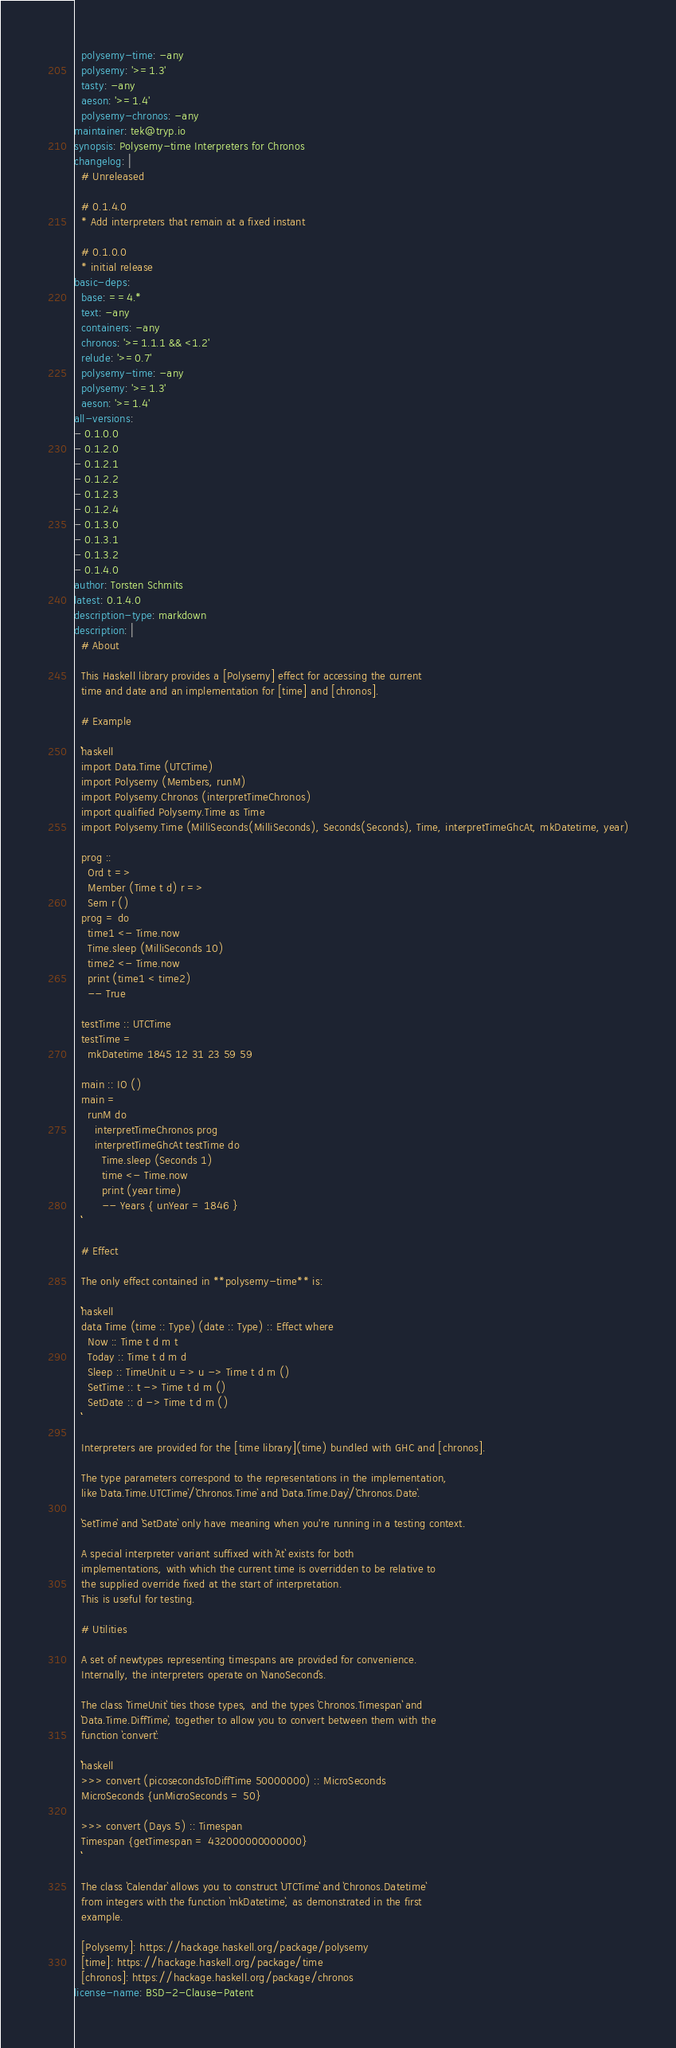Convert code to text. <code><loc_0><loc_0><loc_500><loc_500><_YAML_>  polysemy-time: -any
  polysemy: '>=1.3'
  tasty: -any
  aeson: '>=1.4'
  polysemy-chronos: -any
maintainer: tek@tryp.io
synopsis: Polysemy-time Interpreters for Chronos
changelog: |
  # Unreleased

  # 0.1.4.0
  * Add interpreters that remain at a fixed instant

  # 0.1.0.0
  * initial release
basic-deps:
  base: ==4.*
  text: -any
  containers: -any
  chronos: '>=1.1.1 && <1.2'
  relude: '>=0.7'
  polysemy-time: -any
  polysemy: '>=1.3'
  aeson: '>=1.4'
all-versions:
- 0.1.0.0
- 0.1.2.0
- 0.1.2.1
- 0.1.2.2
- 0.1.2.3
- 0.1.2.4
- 0.1.3.0
- 0.1.3.1
- 0.1.3.2
- 0.1.4.0
author: Torsten Schmits
latest: 0.1.4.0
description-type: markdown
description: |
  # About

  This Haskell library provides a [Polysemy] effect for accessing the current
  time and date and an implementation for [time] and [chronos].

  # Example

  ```haskell
  import Data.Time (UTCTime)
  import Polysemy (Members, runM)
  import Polysemy.Chronos (interpretTimeChronos)
  import qualified Polysemy.Time as Time
  import Polysemy.Time (MilliSeconds(MilliSeconds), Seconds(Seconds), Time, interpretTimeGhcAt, mkDatetime, year)

  prog ::
    Ord t =>
    Member (Time t d) r =>
    Sem r ()
  prog = do
    time1 <- Time.now
    Time.sleep (MilliSeconds 10)
    time2 <- Time.now
    print (time1 < time2)
    -- True

  testTime :: UTCTime
  testTime =
    mkDatetime 1845 12 31 23 59 59

  main :: IO ()
  main =
    runM do
      interpretTimeChronos prog
      interpretTimeGhcAt testTime do
        Time.sleep (Seconds 1)
        time <- Time.now
        print (year time)
        -- Years { unYear = 1846 }
  ```

  # Effect

  The only effect contained in **polysemy-time** is:

  ```haskell
  data Time (time :: Type) (date :: Type) :: Effect where
    Now :: Time t d m t
    Today :: Time t d m d
    Sleep :: TimeUnit u => u -> Time t d m ()
    SetTime :: t -> Time t d m ()
    SetDate :: d -> Time t d m ()
  ```

  Interpreters are provided for the [time library](time) bundled with GHC and [chronos].

  The type parameters correspond to the representations in the implementation,
  like `Data.Time.UTCTime`/`Chronos.Time` and `Data.Time.Day`/`Chronos.Date`.

  `SetTime` and `SetDate` only have meaning when you're running in a testing context.

  A special interpreter variant suffixed with `At` exists for both
  implementations, with which the current time is overridden to be relative to
  the supplied override fixed at the start of interpretation.
  This is useful for testing.

  # Utilities

  A set of newtypes representing timespans are provided for convenience.
  Internally, the interpreters operate on `NanoSecond`s.

  The class `TimeUnit` ties those types, and the types `Chronos.Timespan` and
  `Data.Time.DiffTime`, together to allow you to convert between them with the
  function `convert`:

  ```haskell
  >>> convert (picosecondsToDiffTime 50000000) :: MicroSeconds
  MicroSeconds {unMicroSeconds = 50}

  >>> convert (Days 5) :: Timespan
  Timespan {getTimespan = 432000000000000}
  ```

  The class `Calendar` allows you to construct `UTCTime` and `Chronos.Datetime`
  from integers with the function `mkDatetime`, as demonstrated in the first
  example.

  [Polysemy]: https://hackage.haskell.org/package/polysemy
  [time]: https://hackage.haskell.org/package/time
  [chronos]: https://hackage.haskell.org/package/chronos
license-name: BSD-2-Clause-Patent
</code> 